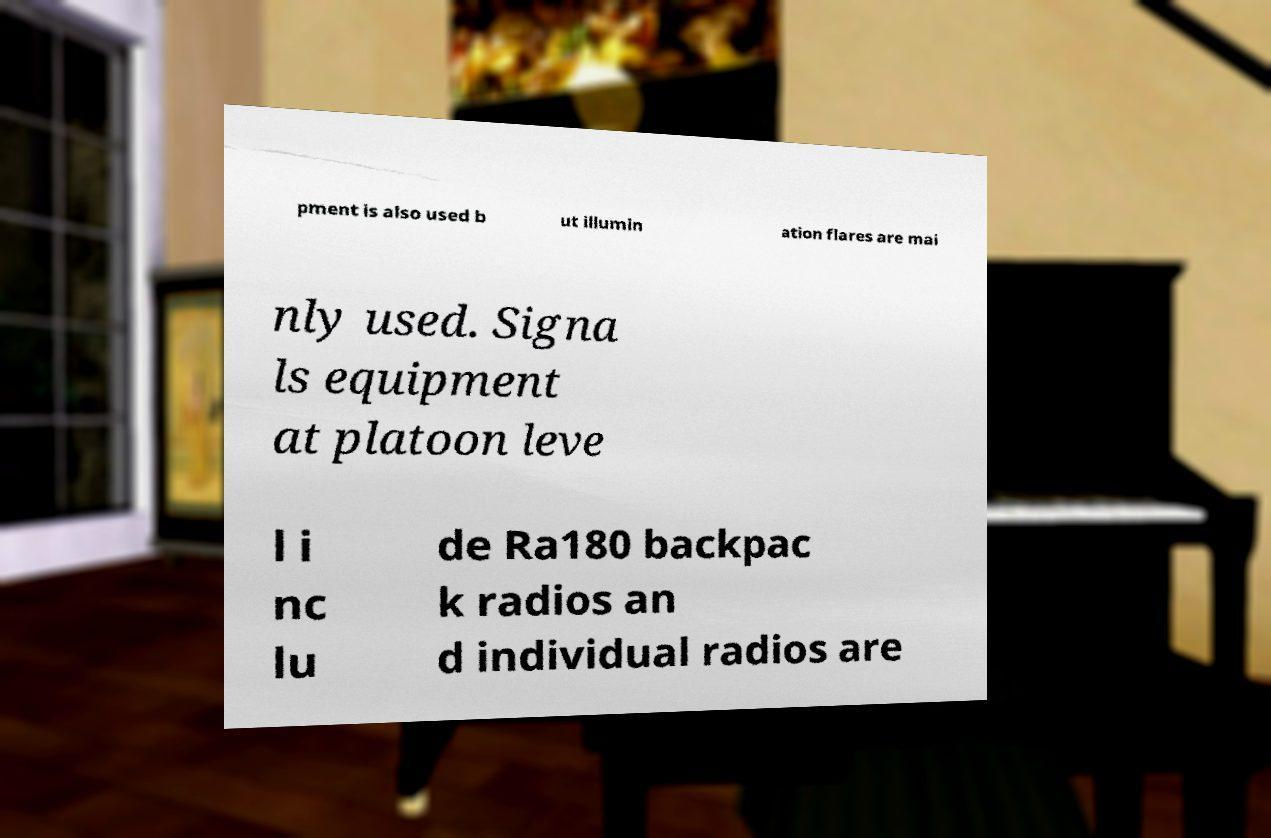Please identify and transcribe the text found in this image. pment is also used b ut illumin ation flares are mai nly used. Signa ls equipment at platoon leve l i nc lu de Ra180 backpac k radios an d individual radios are 